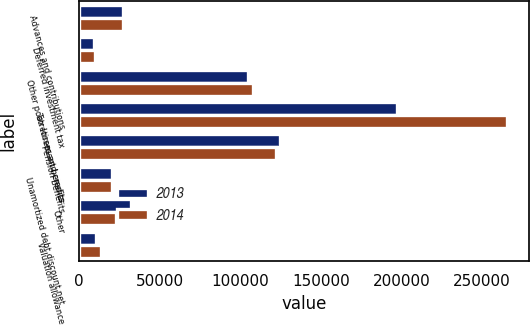Convert chart. <chart><loc_0><loc_0><loc_500><loc_500><stacked_bar_chart><ecel><fcel>Advances and contributions<fcel>Deferred investment tax<fcel>Other postretirement benefits<fcel>Tax losses and credits<fcel>Pension benefits<fcel>Unamortized debt discount net<fcel>Other<fcel>Valuation allowance<nl><fcel>2013<fcel>27580<fcel>9452<fcel>104723<fcel>197288<fcel>124985<fcel>20249<fcel>32159<fcel>10379<nl><fcel>2014<fcel>27580<fcel>10027<fcel>107773<fcel>265640<fcel>122143<fcel>20249<fcel>23001<fcel>13555<nl></chart> 